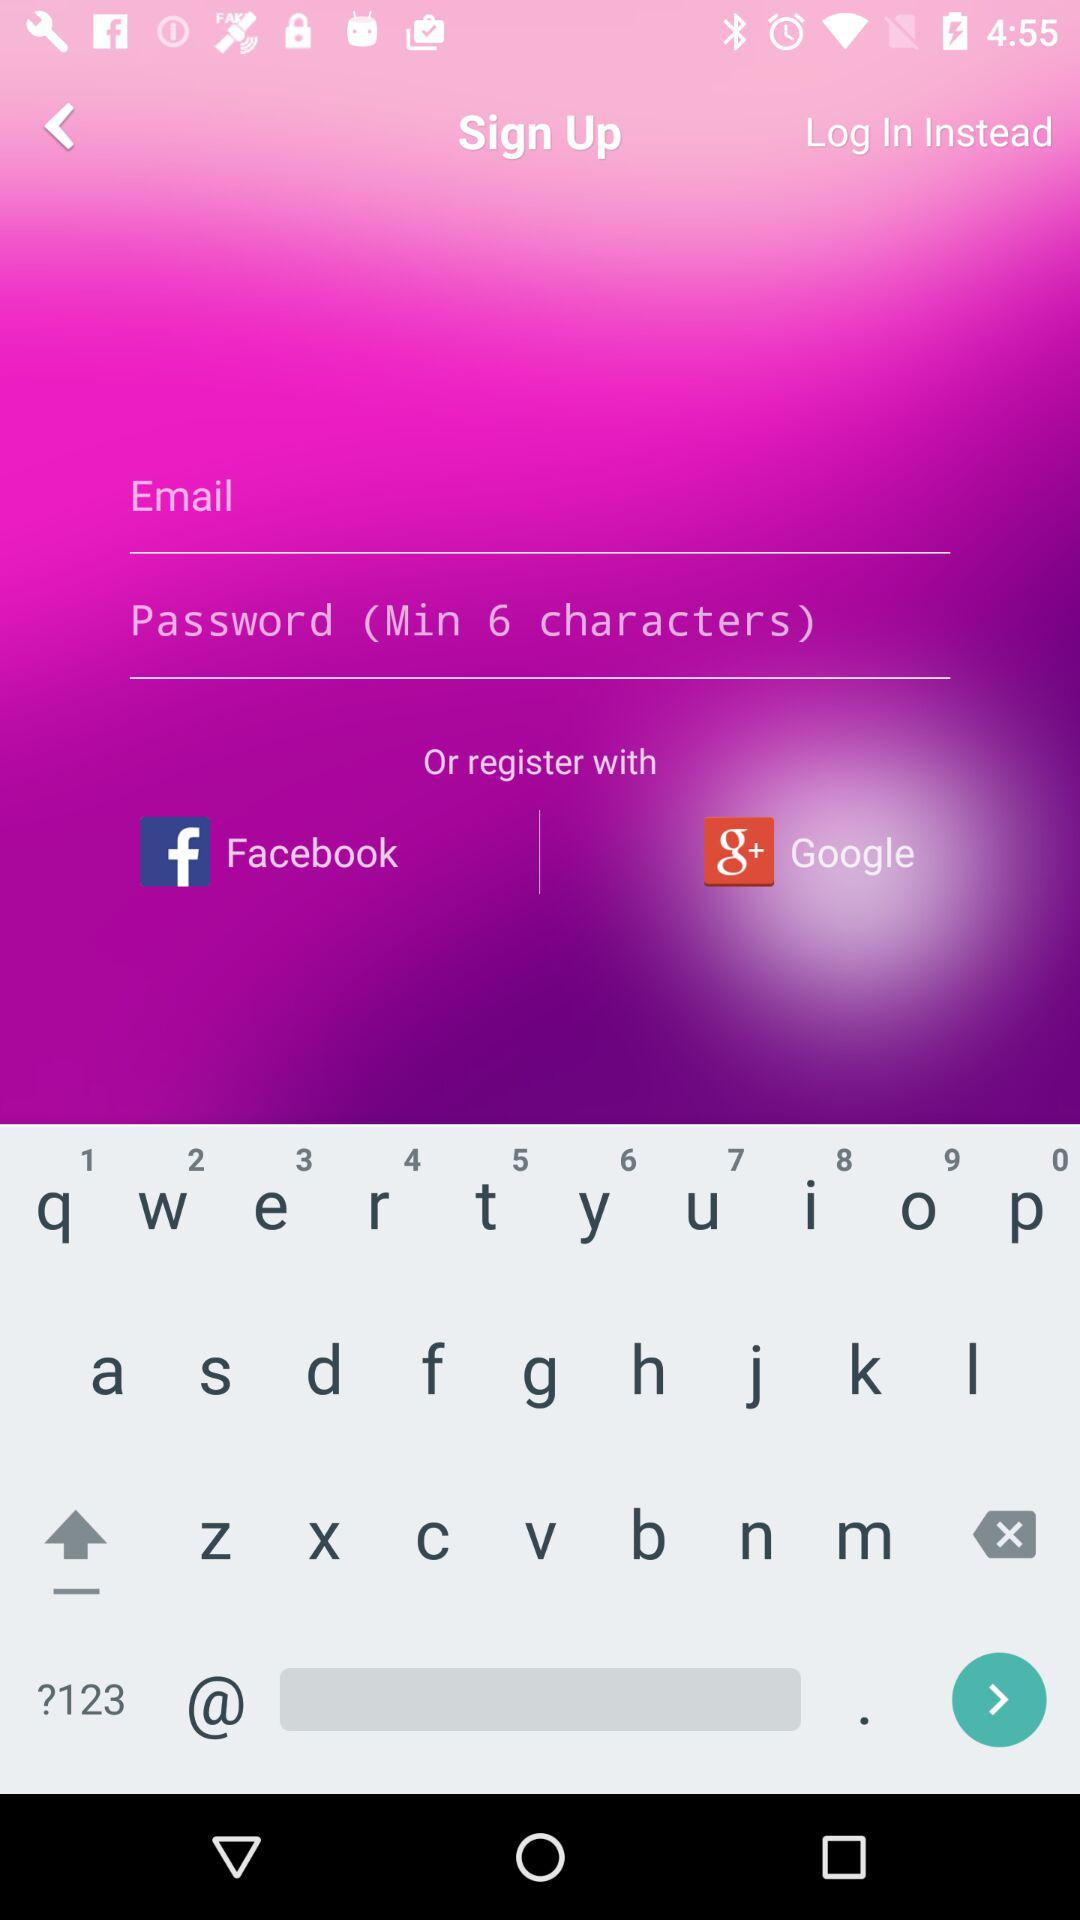What accounts can I use for registration? You can use "Facebook" and "Google". 